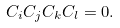<formula> <loc_0><loc_0><loc_500><loc_500>C _ { i } C _ { j } C _ { k } C _ { l } = 0 .</formula> 